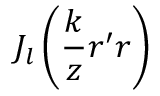Convert formula to latex. <formula><loc_0><loc_0><loc_500><loc_500>J _ { l } \left ( \frac { k } { z } r ^ { \prime } r \right )</formula> 